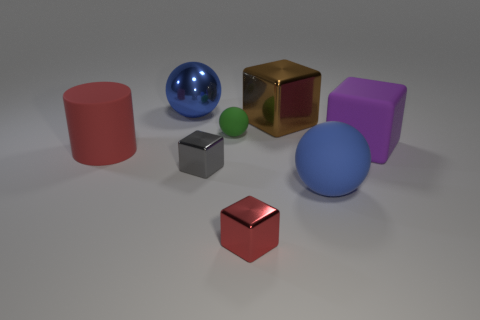Subtract all yellow cubes. Subtract all purple cylinders. How many cubes are left? 4 Add 2 cylinders. How many objects exist? 10 Subtract all cylinders. How many objects are left? 7 Add 4 big objects. How many big objects are left? 9 Add 5 cyan shiny cylinders. How many cyan shiny cylinders exist? 5 Subtract 0 yellow blocks. How many objects are left? 8 Subtract all large purple things. Subtract all red metallic blocks. How many objects are left? 6 